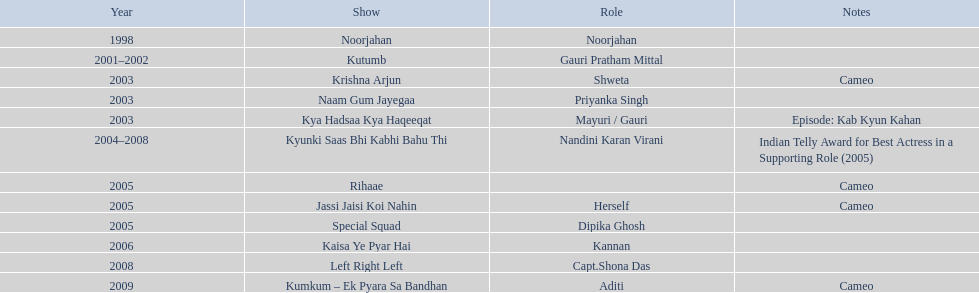What was the initial television show that gauri tejwani participated in? Noorjahan. 